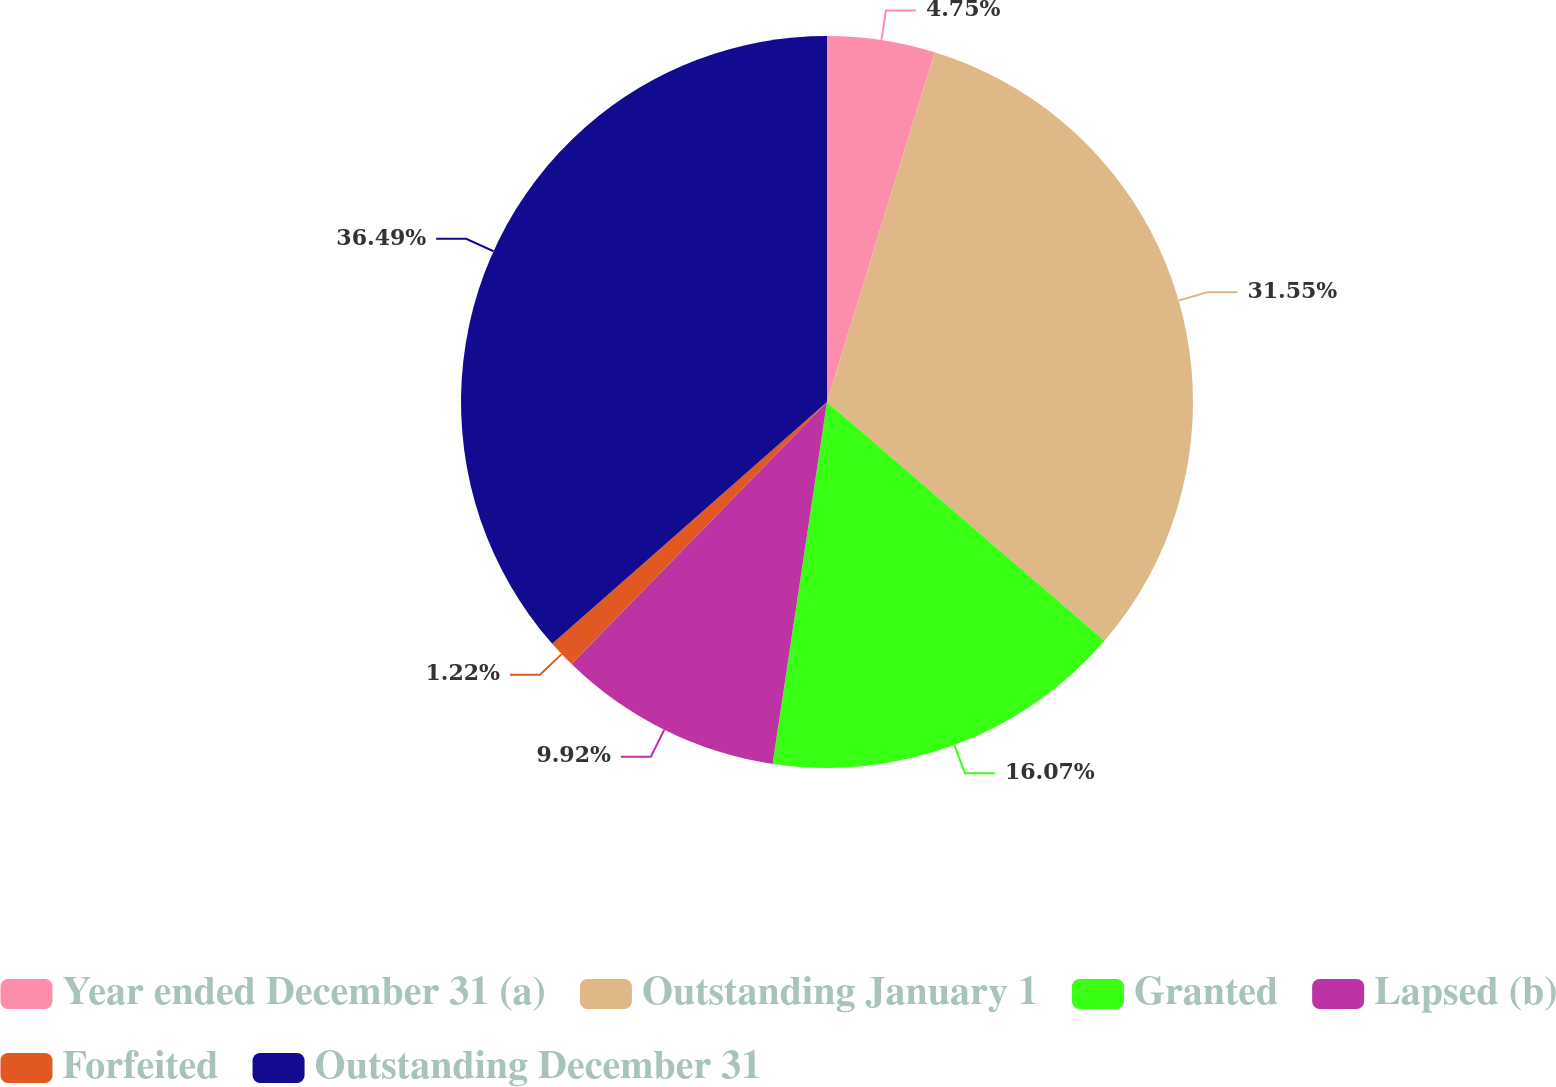<chart> <loc_0><loc_0><loc_500><loc_500><pie_chart><fcel>Year ended December 31 (a)<fcel>Outstanding January 1<fcel>Granted<fcel>Lapsed (b)<fcel>Forfeited<fcel>Outstanding December 31<nl><fcel>4.75%<fcel>31.55%<fcel>16.07%<fcel>9.92%<fcel>1.22%<fcel>36.48%<nl></chart> 